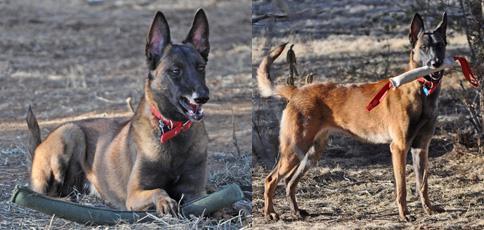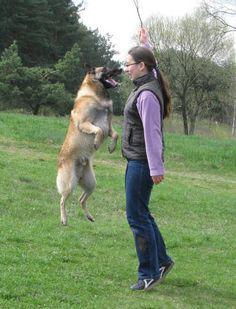The first image is the image on the left, the second image is the image on the right. Given the left and right images, does the statement "There is exactly one human interacting with a dog." hold true? Answer yes or no. Yes. 